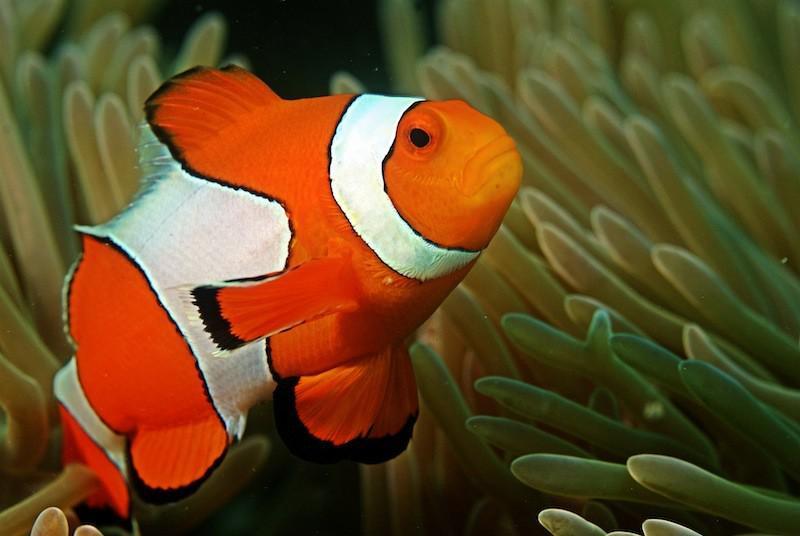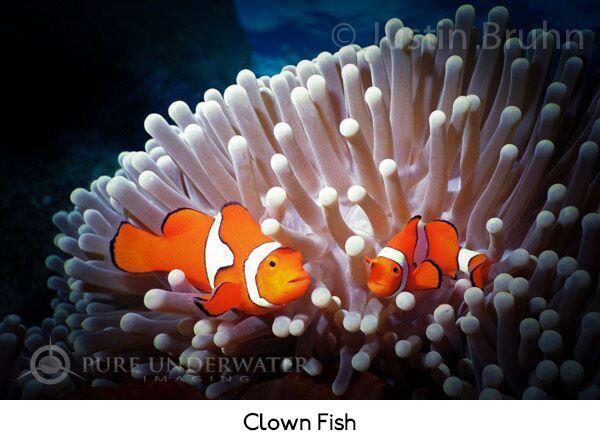The first image is the image on the left, the second image is the image on the right. Examine the images to the left and right. Is the description "Each image shows clown fish swimming among anemone tendrils, but the right image contains at least twice as many clown fish." accurate? Answer yes or no. Yes. 